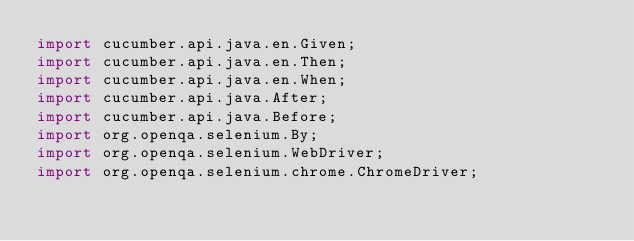Convert code to text. <code><loc_0><loc_0><loc_500><loc_500><_Java_>import cucumber.api.java.en.Given;
import cucumber.api.java.en.Then;
import cucumber.api.java.en.When;
import cucumber.api.java.After;
import cucumber.api.java.Before;
import org.openqa.selenium.By;
import org.openqa.selenium.WebDriver;
import org.openqa.selenium.chrome.ChromeDriver;</code> 